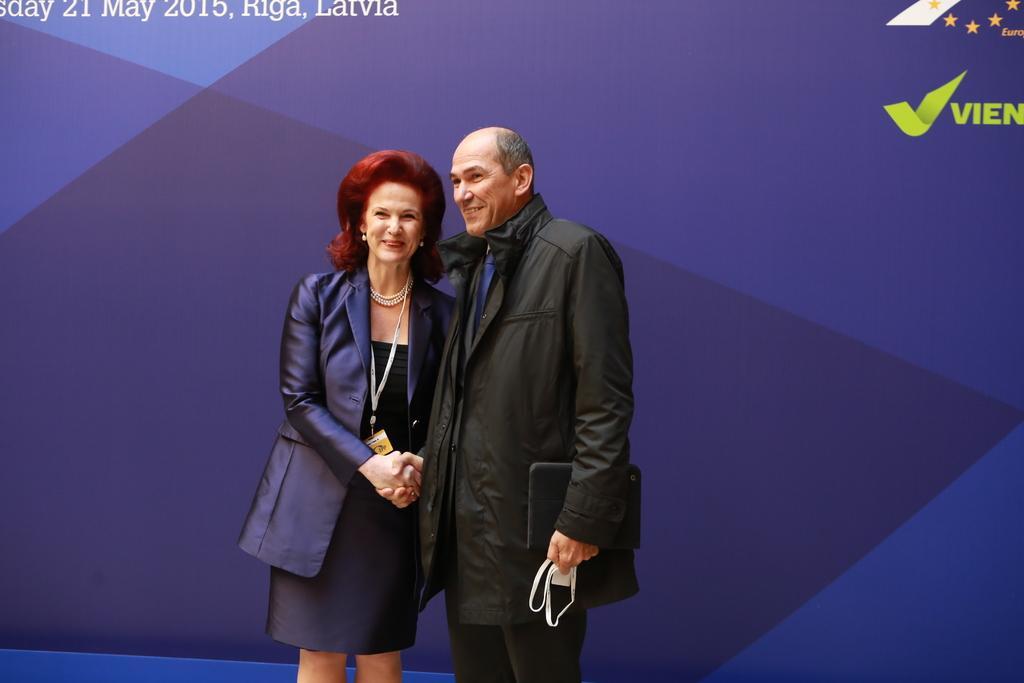Describe this image in one or two sentences. In this image there are two persons standing and shake hands to each other with a smile on their face, one of them is holding an object in his hand. 